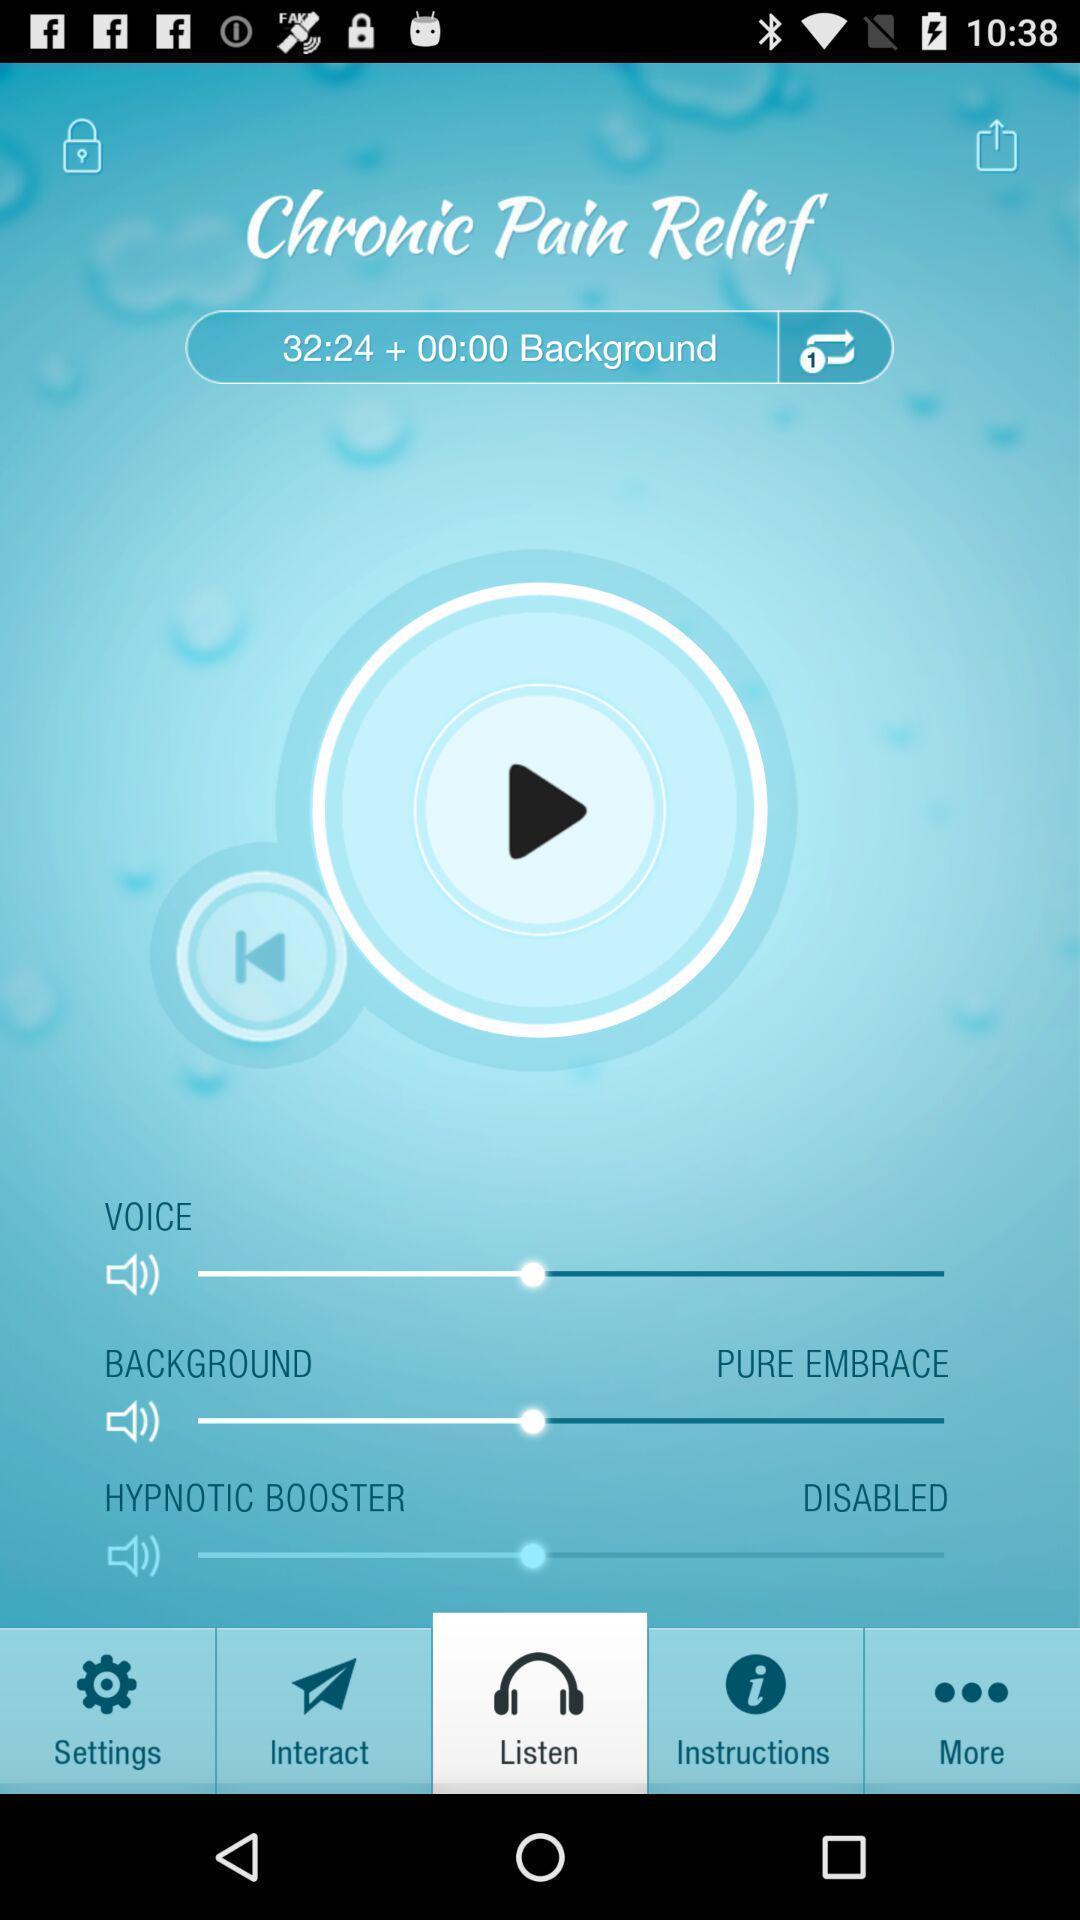Give me a narrative description of this picture. Various settings and preferences displayed of sound mixing app. 